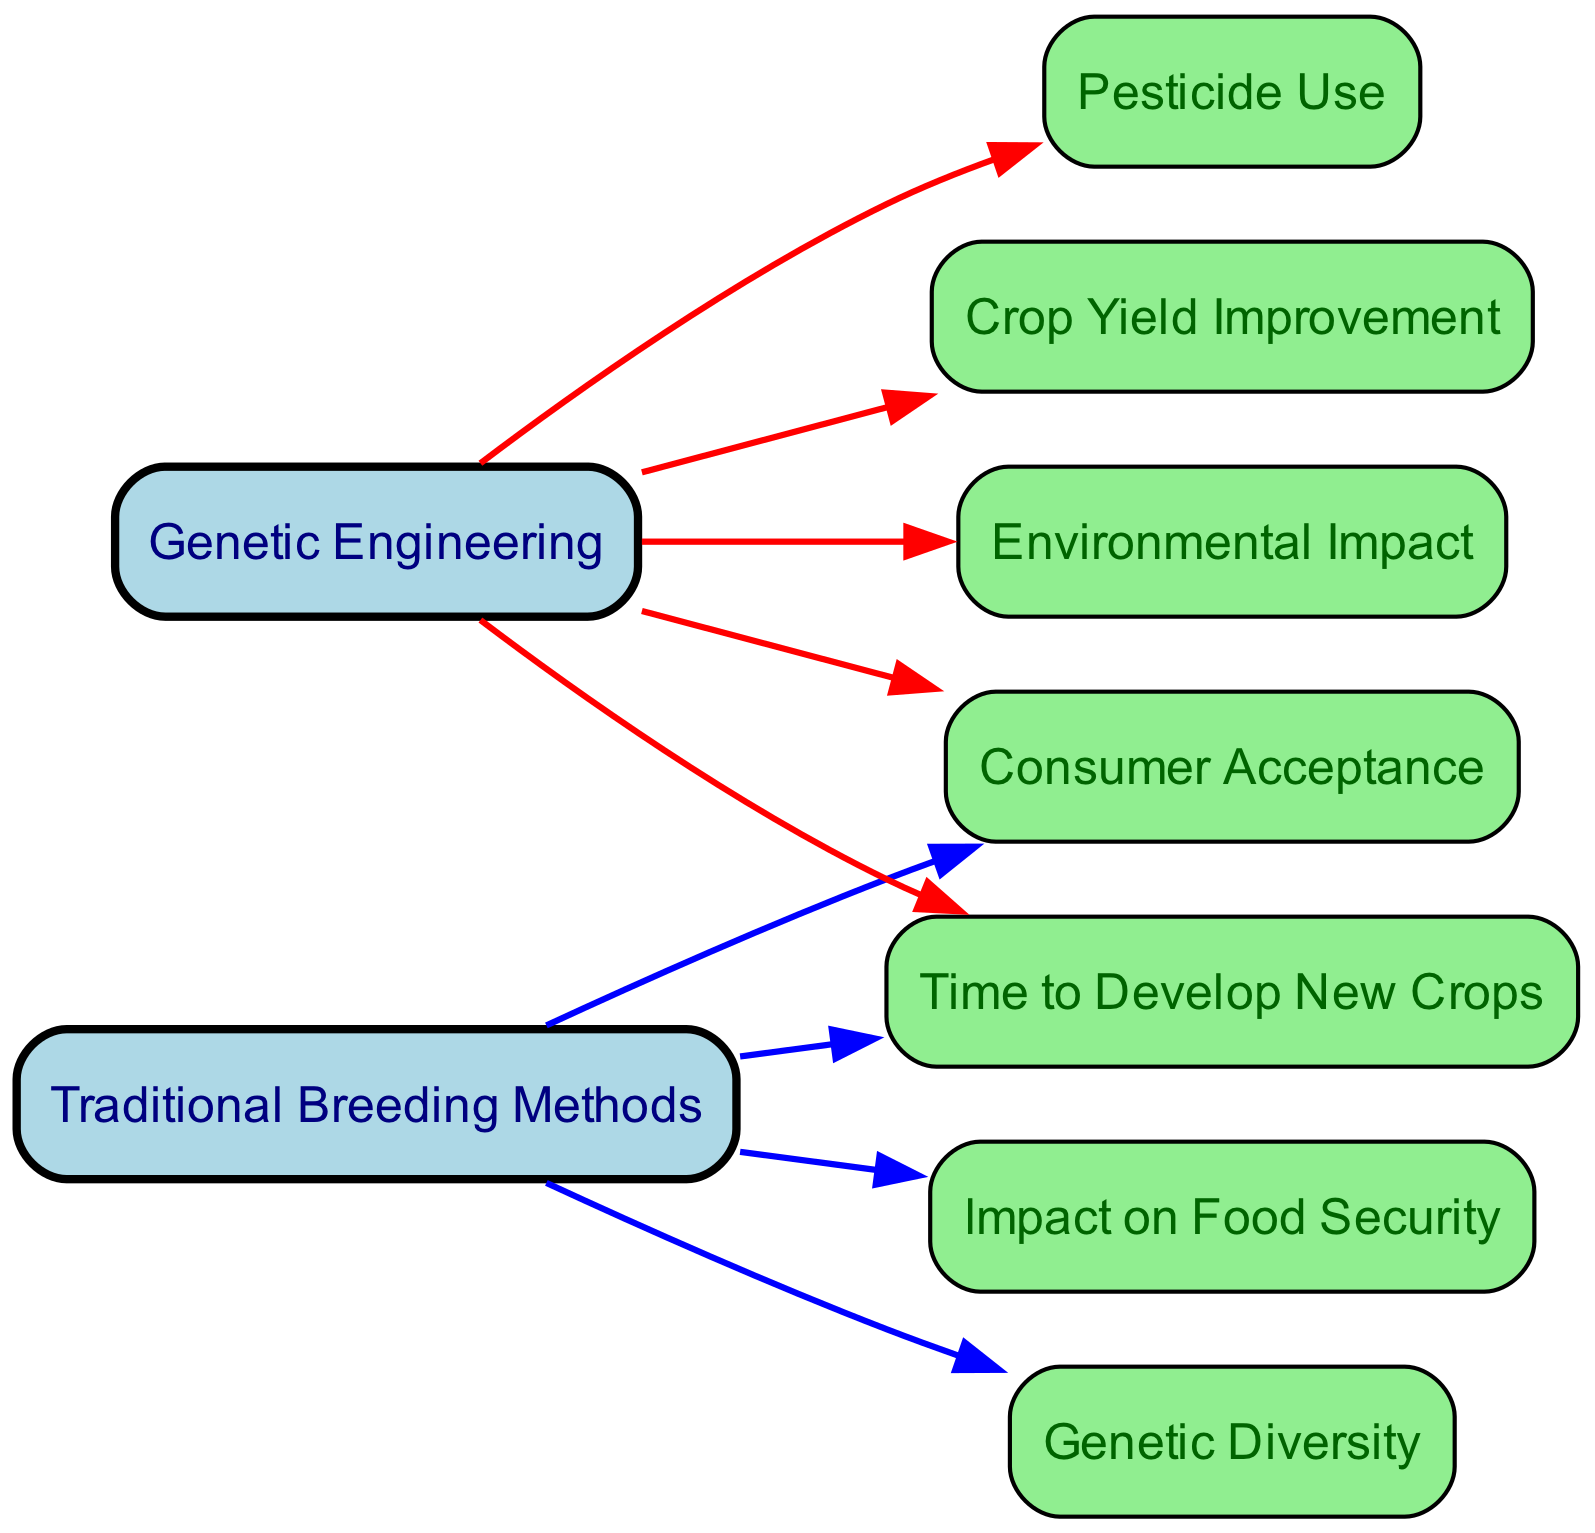What are the two primary methods of crop development shown in the diagram? The diagram features two main nodes: "Traditional Breeding Methods" and "Genetic Engineering". These nodes represent the two approaches to developing new crops.
Answer: Traditional Breeding Methods, Genetic Engineering How many edges are connected to the "Genetic Engineering" node? Counting the edges that lead from the "Genetic Engineering" node, I see four outgoing edges to "Time to Develop New Crops", "Pesticide Use", "Crop Yield Improvement", and "Environmental Impact". This totals four edges.
Answer: 4 Which method is associated with a shorter "Time to Develop New Crops"? "Genetic Engineering" is linked to the "Time to Develop New Crops" node and is designed to be quicker in developing new crop varieties compared to "Traditional Breeding Methods", which typically require more time.
Answer: Genetic Engineering What is the relationship between "Traditional Breeding Methods" and "Genetic Diversity"? "Traditional Breeding Methods" connects directly to "Genetic Diversity", suggesting that this method often promotes increased genetic diversity in crops compared to genetic engineering, which might limit diversity as it focuses on specific traits.
Answer: Promotes genetic diversity Which two nodes are connected to "Consumer Acceptance"? The "Consumer Acceptance" node is connected to both "Traditional Breeding Methods" and "Genetic Engineering", indicating that both methods are important in shaping how consumers view the crops produced through these techniques.
Answer: Traditional Breeding Methods, Genetic Engineering What impact does "Genetic Engineering" have on "Pesticide Use"? The edge leading from "Genetic Engineering" to "Pesticide Use" shows a relationship where genetic modifications may lead to reduced pesticide usage, likely due to the development of crops resistant to pests.
Answer: Reduced pesticide use In terms of environmental impact, which method is generally considered to pose a lower risk? "Genetic Engineering" is connected to "Environmental Impact", and waves the potential to reduce negative impacts through more targeted interventions, unlike traditional methods which might affect biodiversity more broadly.
Answer: Genetic Engineering How many nodes are linked to "Food Security"? Only one node, "Food Security", is connected to "Traditional Breeding Methods", showing a direct focus on how traditional approaches aim to address food security by improving crop yields over time.
Answer: 1 